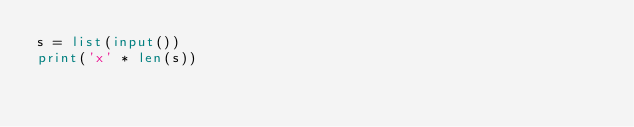Convert code to text. <code><loc_0><loc_0><loc_500><loc_500><_Python_>s = list(input())
print('x' * len(s))</code> 